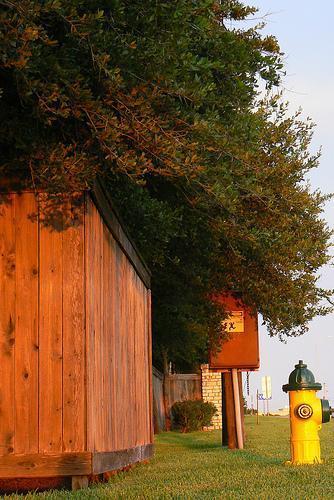How many fire hydrants are shown?
Give a very brief answer. 1. 